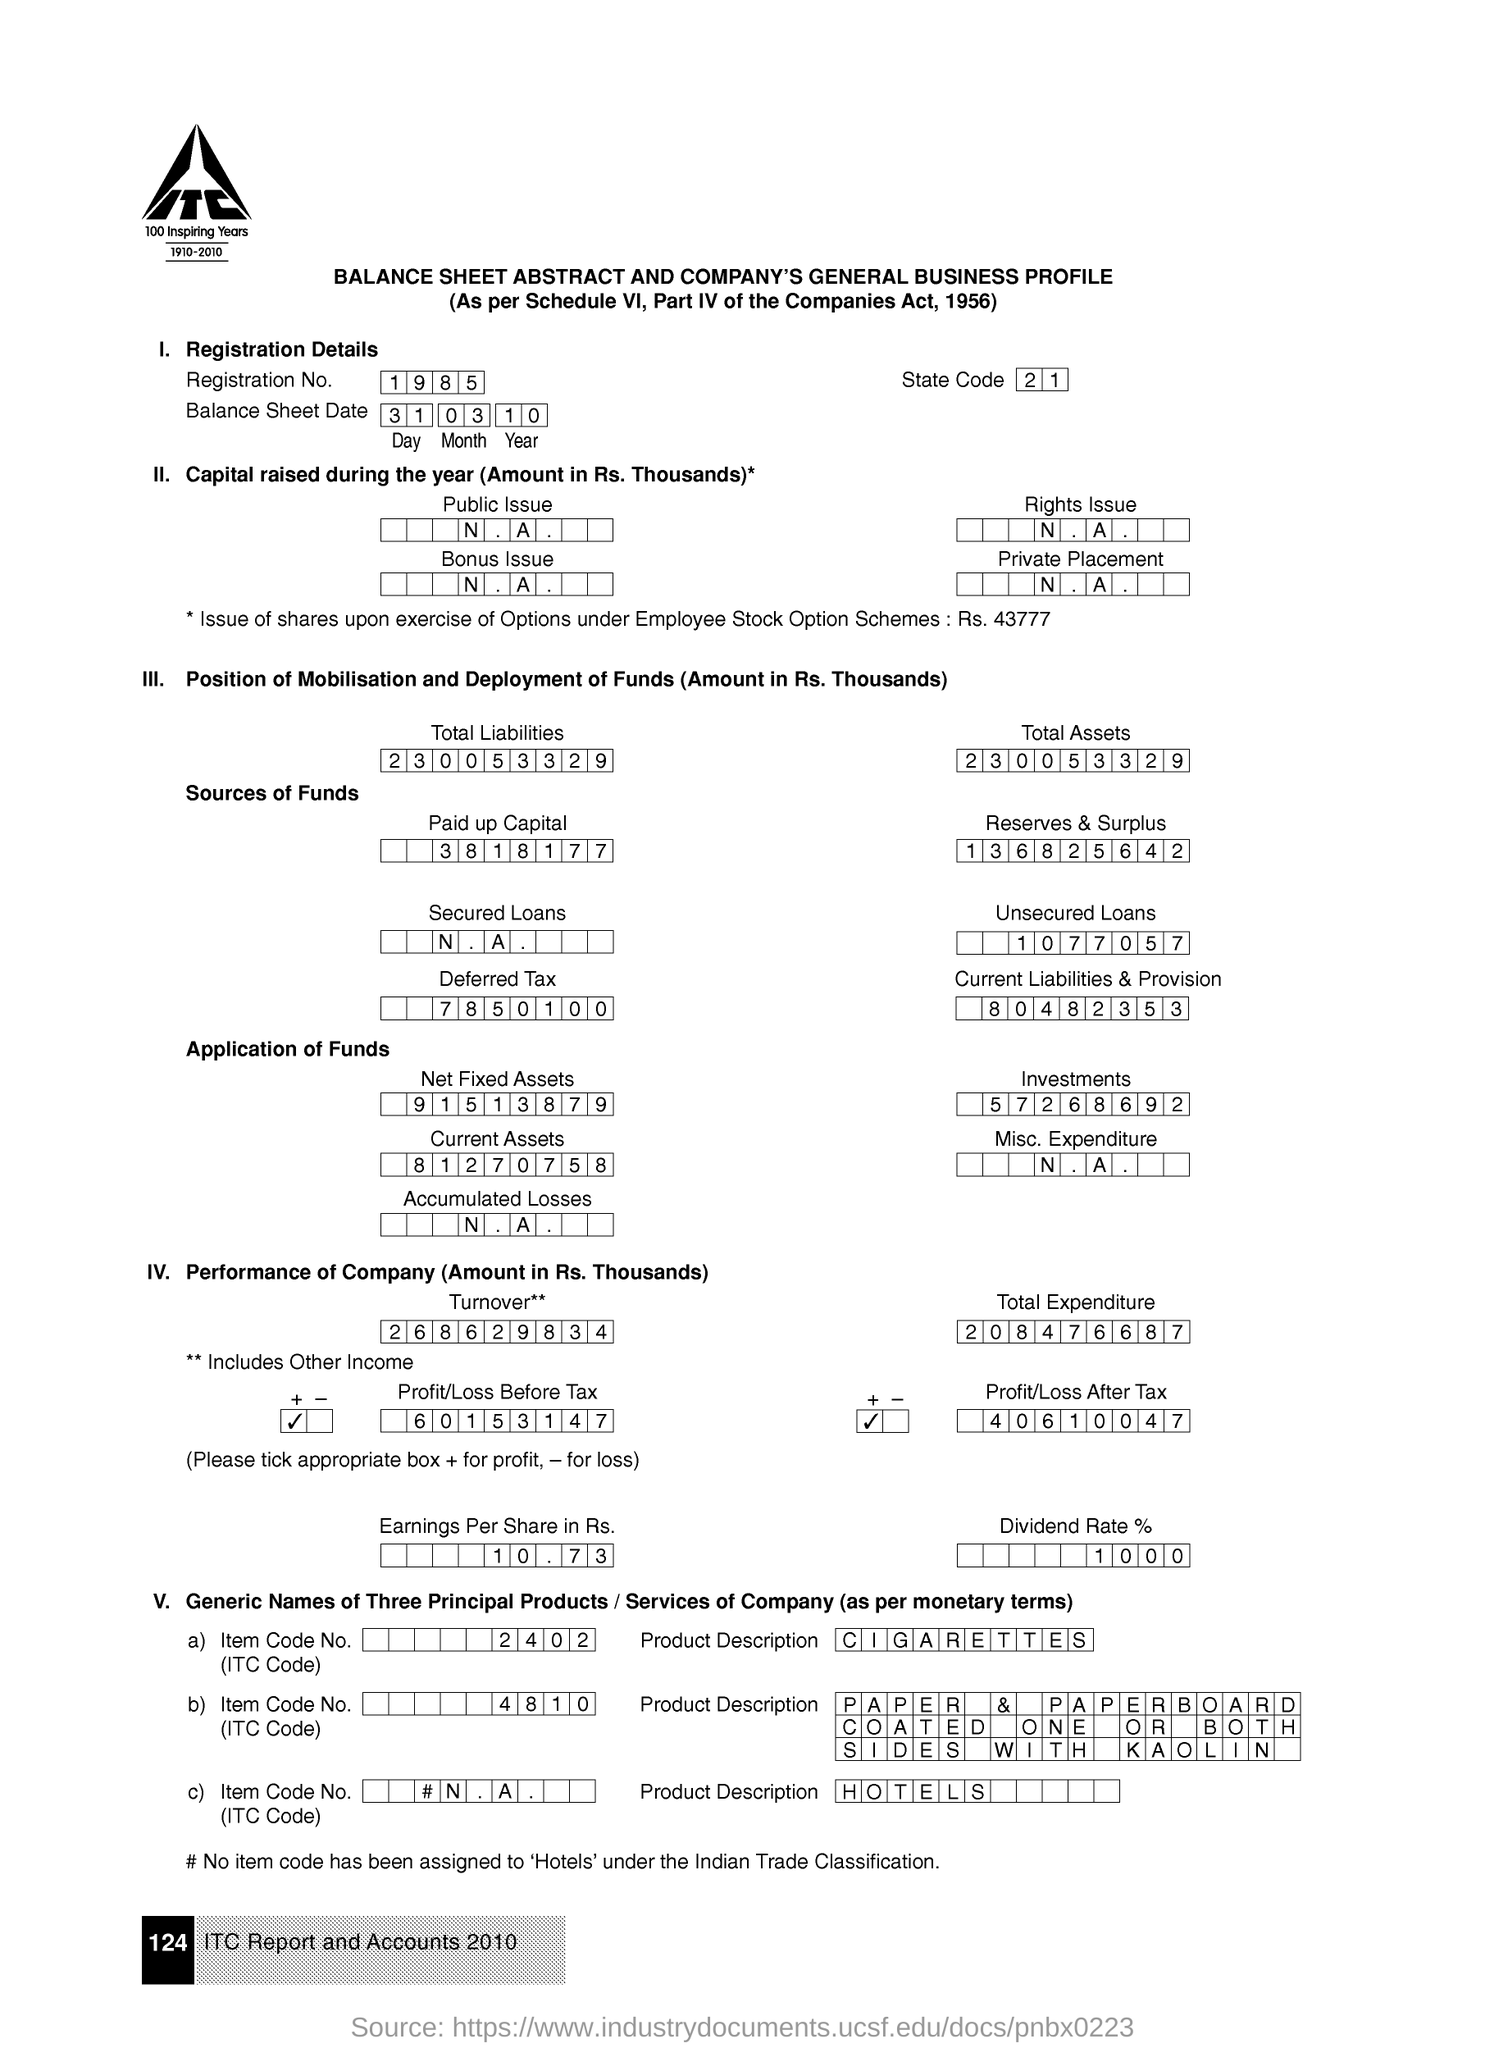What is the state code as per this document?
Give a very brief answer. 21. 